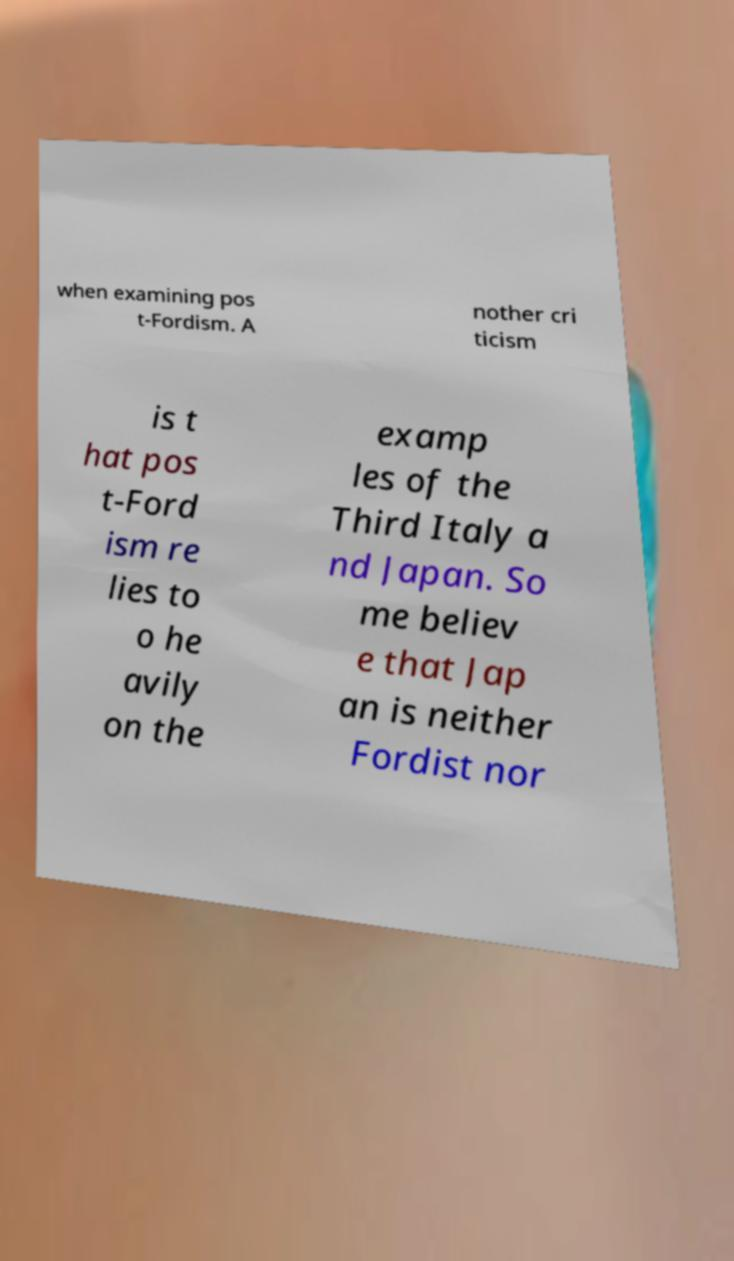What messages or text are displayed in this image? I need them in a readable, typed format. when examining pos t-Fordism. A nother cri ticism is t hat pos t-Ford ism re lies to o he avily on the examp les of the Third Italy a nd Japan. So me believ e that Jap an is neither Fordist nor 